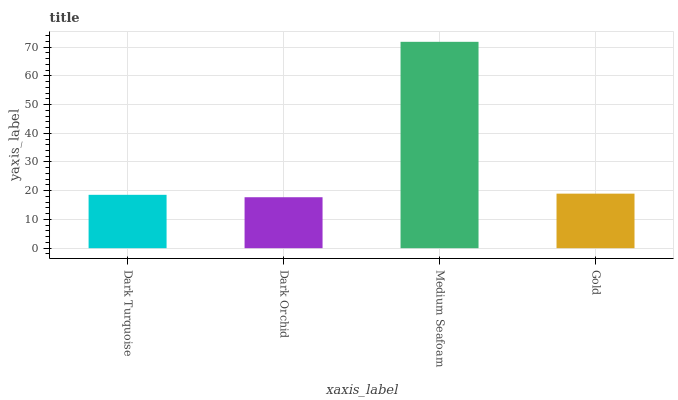Is Dark Orchid the minimum?
Answer yes or no. Yes. Is Medium Seafoam the maximum?
Answer yes or no. Yes. Is Medium Seafoam the minimum?
Answer yes or no. No. Is Dark Orchid the maximum?
Answer yes or no. No. Is Medium Seafoam greater than Dark Orchid?
Answer yes or no. Yes. Is Dark Orchid less than Medium Seafoam?
Answer yes or no. Yes. Is Dark Orchid greater than Medium Seafoam?
Answer yes or no. No. Is Medium Seafoam less than Dark Orchid?
Answer yes or no. No. Is Gold the high median?
Answer yes or no. Yes. Is Dark Turquoise the low median?
Answer yes or no. Yes. Is Medium Seafoam the high median?
Answer yes or no. No. Is Dark Orchid the low median?
Answer yes or no. No. 